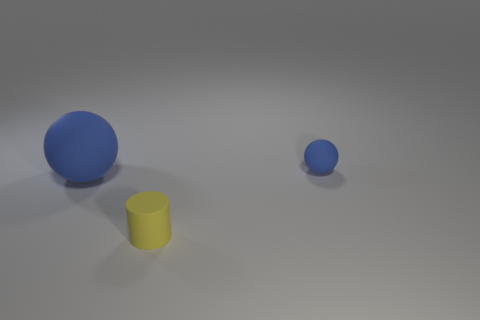Subtract all cylinders. How many objects are left? 2 Add 3 small purple things. How many objects exist? 6 Subtract 1 cylinders. How many cylinders are left? 0 Add 1 big balls. How many big balls exist? 2 Subtract 2 blue balls. How many objects are left? 1 Subtract all brown spheres. Subtract all yellow cylinders. How many spheres are left? 2 Subtract all red cylinders. Subtract all big blue objects. How many objects are left? 2 Add 2 yellow cylinders. How many yellow cylinders are left? 3 